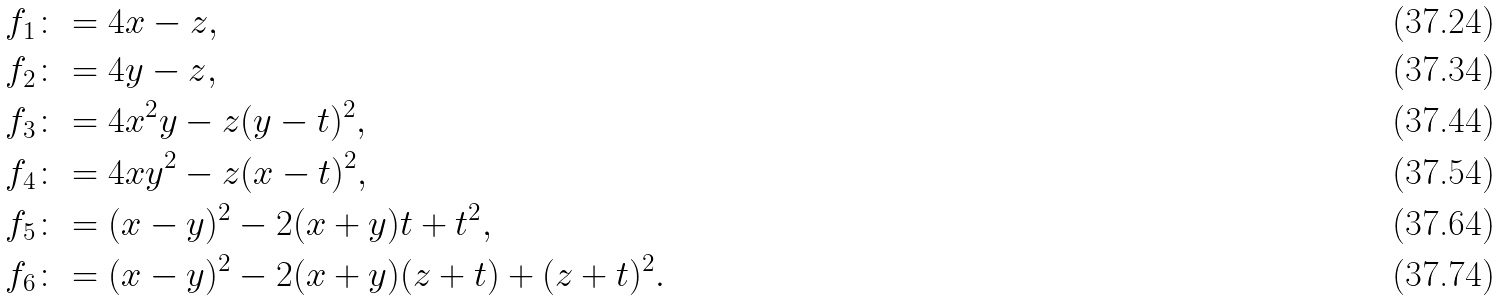Convert formula to latex. <formula><loc_0><loc_0><loc_500><loc_500>f _ { 1 } & \colon = 4 x - z , \\ f _ { 2 } & \colon = 4 y - z , \\ f _ { 3 } & \colon = 4 x ^ { 2 } y - z ( y - t ) ^ { 2 } , \\ f _ { 4 } & \colon = 4 x y ^ { 2 } - z ( x - t ) ^ { 2 } , \\ f _ { 5 } & \colon = ( x - y ) ^ { 2 } - 2 ( x + y ) t + t ^ { 2 } , \\ f _ { 6 } & \colon = ( x - y ) ^ { 2 } - 2 ( x + y ) ( z + t ) + ( z + t ) ^ { 2 } .</formula> 